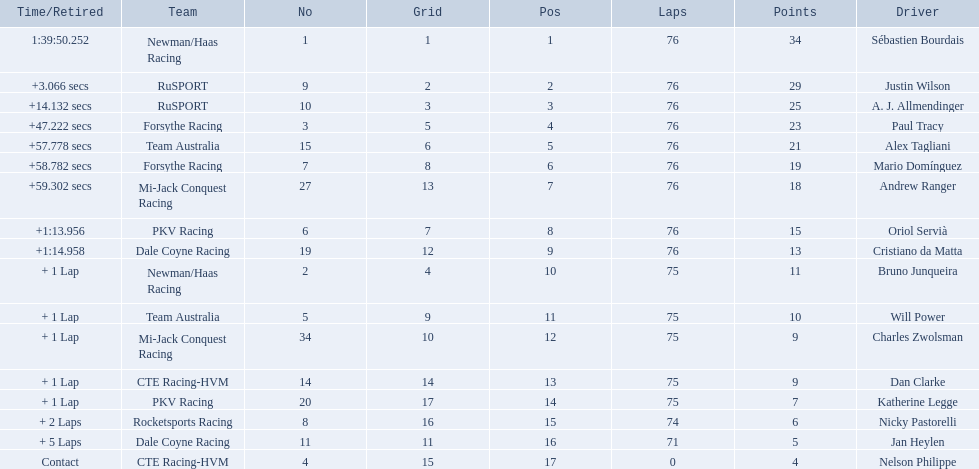What was alex taglini's final score in the tecate grand prix? 21. What was paul tracy's final score in the tecate grand prix? 23. Which driver finished first? Paul Tracy. 